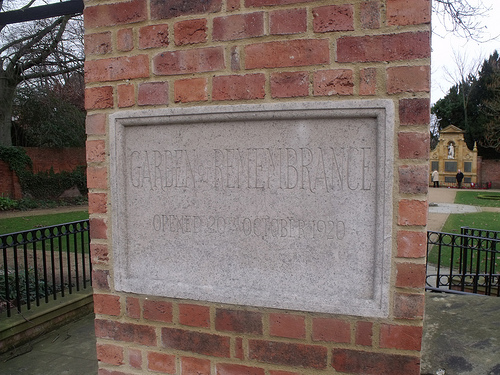<image>
Is the board in the wall? Yes. The board is contained within or inside the wall, showing a containment relationship. 